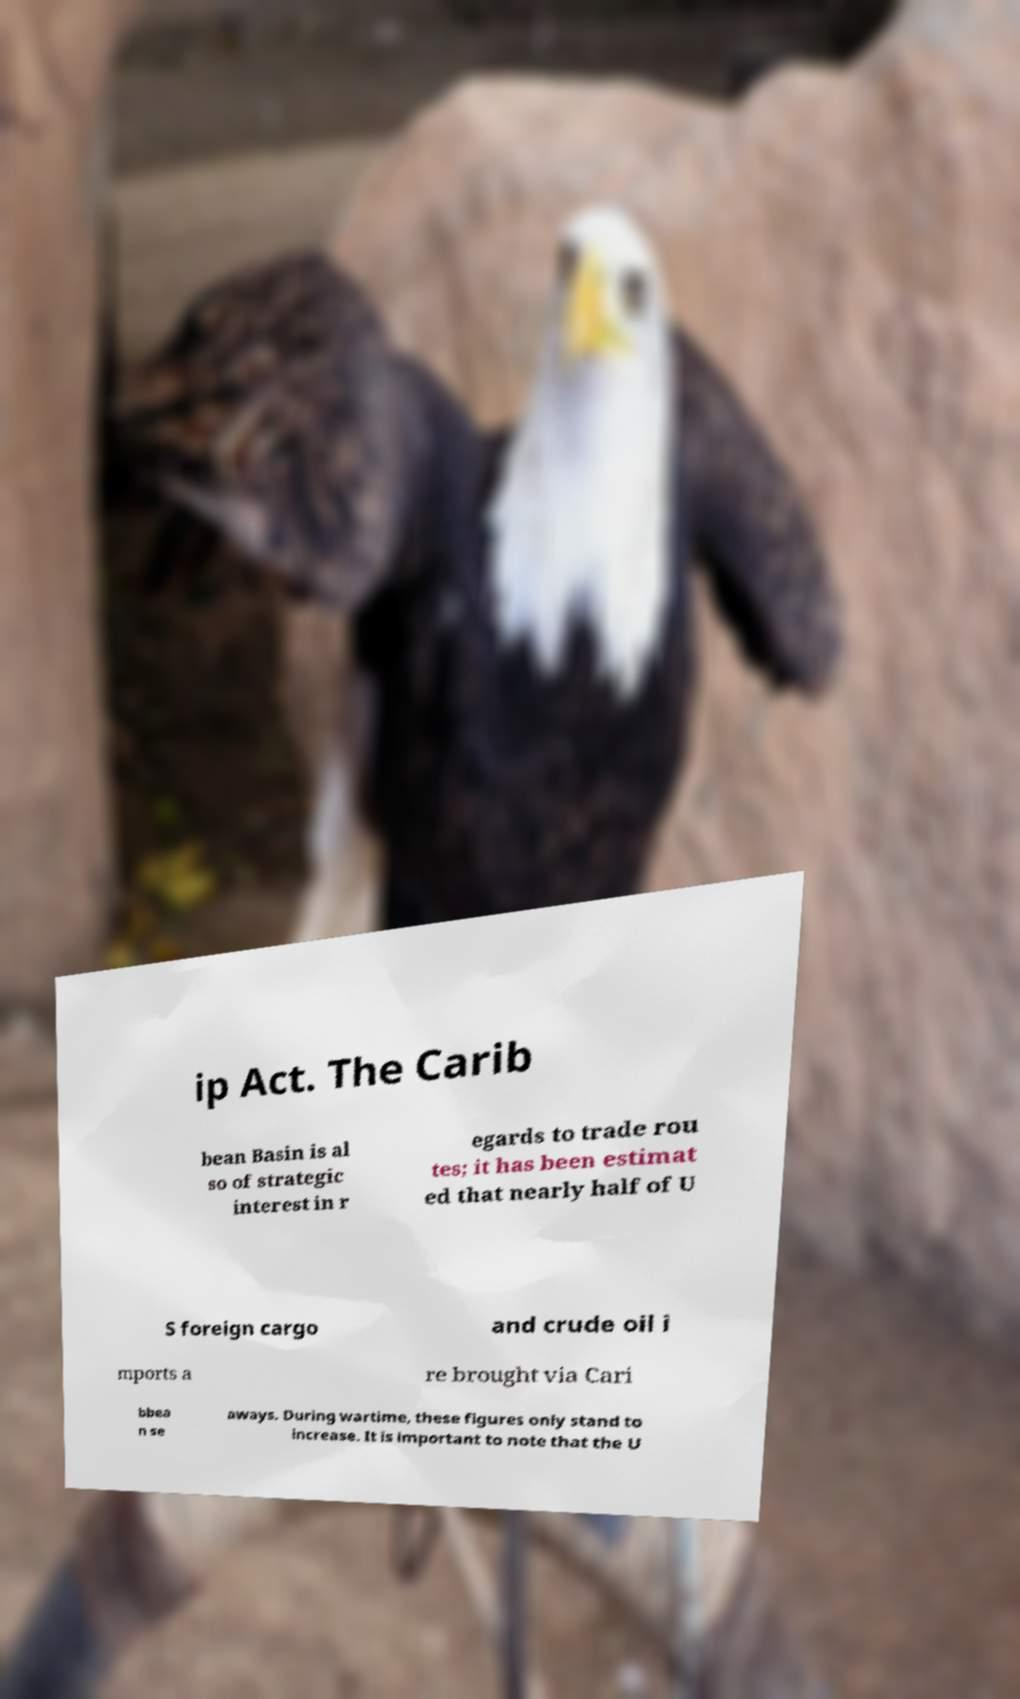Could you extract and type out the text from this image? ip Act. The Carib bean Basin is al so of strategic interest in r egards to trade rou tes; it has been estimat ed that nearly half of U S foreign cargo and crude oil i mports a re brought via Cari bbea n se aways. During wartime, these figures only stand to increase. It is important to note that the U 